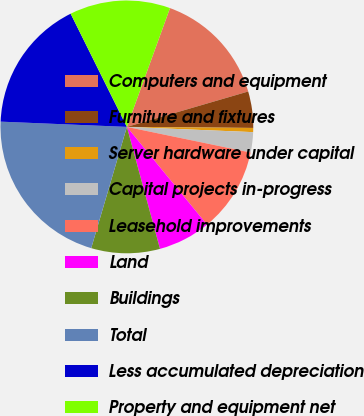Convert chart to OTSL. <chart><loc_0><loc_0><loc_500><loc_500><pie_chart><fcel>Computers and equipment<fcel>Furniture and fixtures<fcel>Server hardware under capital<fcel>Capital projects in-progress<fcel>Leasehold improvements<fcel>Land<fcel>Buildings<fcel>Total<fcel>Less accumulated depreciation<fcel>Property and equipment net<nl><fcel>14.94%<fcel>4.65%<fcel>0.53%<fcel>2.59%<fcel>10.82%<fcel>6.71%<fcel>8.77%<fcel>21.11%<fcel>17.0%<fcel>12.88%<nl></chart> 